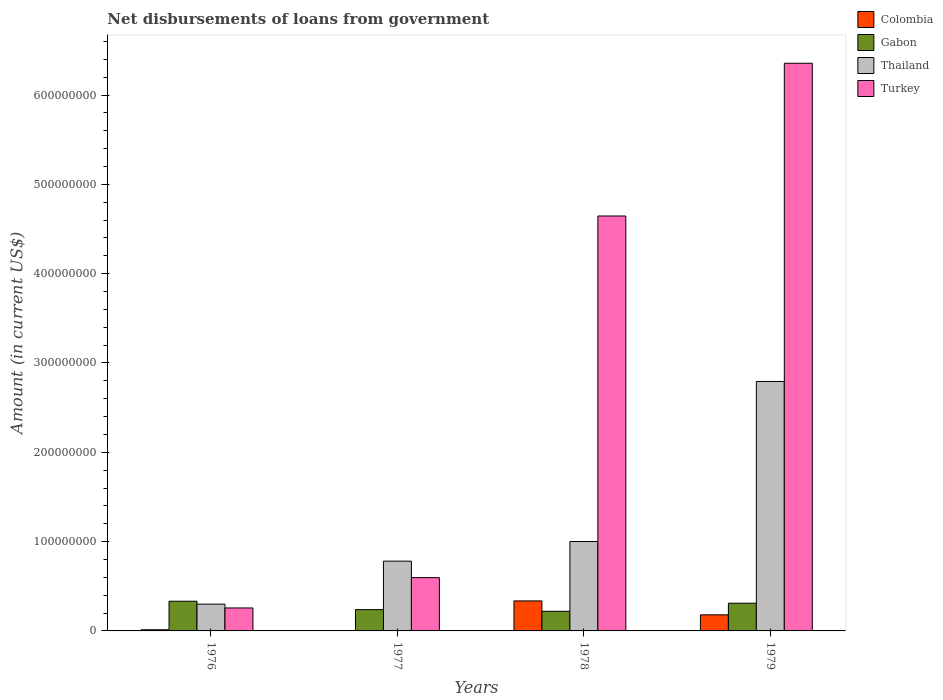How many different coloured bars are there?
Ensure brevity in your answer.  4. Are the number of bars on each tick of the X-axis equal?
Ensure brevity in your answer.  No. How many bars are there on the 2nd tick from the left?
Offer a very short reply. 3. What is the label of the 3rd group of bars from the left?
Your answer should be very brief. 1978. In how many cases, is the number of bars for a given year not equal to the number of legend labels?
Your answer should be very brief. 1. What is the amount of loan disbursed from government in Gabon in 1976?
Offer a terse response. 3.32e+07. Across all years, what is the maximum amount of loan disbursed from government in Thailand?
Offer a very short reply. 2.79e+08. Across all years, what is the minimum amount of loan disbursed from government in Gabon?
Your answer should be very brief. 2.20e+07. In which year was the amount of loan disbursed from government in Turkey maximum?
Your answer should be compact. 1979. What is the total amount of loan disbursed from government in Thailand in the graph?
Your answer should be very brief. 4.88e+08. What is the difference between the amount of loan disbursed from government in Thailand in 1976 and that in 1978?
Keep it short and to the point. -7.01e+07. What is the difference between the amount of loan disbursed from government in Gabon in 1978 and the amount of loan disbursed from government in Turkey in 1979?
Keep it short and to the point. -6.14e+08. What is the average amount of loan disbursed from government in Turkey per year?
Your answer should be compact. 2.96e+08. In the year 1976, what is the difference between the amount of loan disbursed from government in Thailand and amount of loan disbursed from government in Colombia?
Offer a terse response. 2.87e+07. What is the ratio of the amount of loan disbursed from government in Turkey in 1978 to that in 1979?
Your answer should be compact. 0.73. Is the amount of loan disbursed from government in Gabon in 1976 less than that in 1977?
Provide a succinct answer. No. What is the difference between the highest and the second highest amount of loan disbursed from government in Gabon?
Offer a very short reply. 2.24e+06. What is the difference between the highest and the lowest amount of loan disbursed from government in Colombia?
Provide a succinct answer. 3.36e+07. In how many years, is the amount of loan disbursed from government in Gabon greater than the average amount of loan disbursed from government in Gabon taken over all years?
Offer a very short reply. 2. Are the values on the major ticks of Y-axis written in scientific E-notation?
Keep it short and to the point. No. Does the graph contain any zero values?
Make the answer very short. Yes. Does the graph contain grids?
Your answer should be compact. No. How many legend labels are there?
Offer a very short reply. 4. How are the legend labels stacked?
Provide a short and direct response. Vertical. What is the title of the graph?
Provide a short and direct response. Net disbursements of loans from government. What is the Amount (in current US$) in Colombia in 1976?
Ensure brevity in your answer.  1.31e+06. What is the Amount (in current US$) of Gabon in 1976?
Give a very brief answer. 3.32e+07. What is the Amount (in current US$) in Thailand in 1976?
Keep it short and to the point. 3.00e+07. What is the Amount (in current US$) in Turkey in 1976?
Offer a terse response. 2.57e+07. What is the Amount (in current US$) of Colombia in 1977?
Keep it short and to the point. 0. What is the Amount (in current US$) in Gabon in 1977?
Keep it short and to the point. 2.38e+07. What is the Amount (in current US$) of Thailand in 1977?
Offer a terse response. 7.81e+07. What is the Amount (in current US$) in Turkey in 1977?
Provide a succinct answer. 5.97e+07. What is the Amount (in current US$) of Colombia in 1978?
Your response must be concise. 3.36e+07. What is the Amount (in current US$) in Gabon in 1978?
Offer a very short reply. 2.20e+07. What is the Amount (in current US$) of Thailand in 1978?
Your answer should be compact. 1.00e+08. What is the Amount (in current US$) in Turkey in 1978?
Make the answer very short. 4.65e+08. What is the Amount (in current US$) in Colombia in 1979?
Offer a very short reply. 1.80e+07. What is the Amount (in current US$) in Gabon in 1979?
Keep it short and to the point. 3.10e+07. What is the Amount (in current US$) of Thailand in 1979?
Provide a succinct answer. 2.79e+08. What is the Amount (in current US$) in Turkey in 1979?
Ensure brevity in your answer.  6.36e+08. Across all years, what is the maximum Amount (in current US$) of Colombia?
Keep it short and to the point. 3.36e+07. Across all years, what is the maximum Amount (in current US$) of Gabon?
Your response must be concise. 3.32e+07. Across all years, what is the maximum Amount (in current US$) of Thailand?
Your answer should be very brief. 2.79e+08. Across all years, what is the maximum Amount (in current US$) in Turkey?
Your answer should be compact. 6.36e+08. Across all years, what is the minimum Amount (in current US$) in Colombia?
Provide a succinct answer. 0. Across all years, what is the minimum Amount (in current US$) of Gabon?
Offer a very short reply. 2.20e+07. Across all years, what is the minimum Amount (in current US$) in Thailand?
Offer a terse response. 3.00e+07. Across all years, what is the minimum Amount (in current US$) of Turkey?
Your response must be concise. 2.57e+07. What is the total Amount (in current US$) of Colombia in the graph?
Offer a terse response. 5.29e+07. What is the total Amount (in current US$) of Gabon in the graph?
Your answer should be very brief. 1.10e+08. What is the total Amount (in current US$) of Thailand in the graph?
Provide a succinct answer. 4.88e+08. What is the total Amount (in current US$) in Turkey in the graph?
Offer a terse response. 1.19e+09. What is the difference between the Amount (in current US$) in Gabon in 1976 and that in 1977?
Make the answer very short. 9.41e+06. What is the difference between the Amount (in current US$) in Thailand in 1976 and that in 1977?
Make the answer very short. -4.81e+07. What is the difference between the Amount (in current US$) of Turkey in 1976 and that in 1977?
Offer a very short reply. -3.40e+07. What is the difference between the Amount (in current US$) in Colombia in 1976 and that in 1978?
Offer a terse response. -3.23e+07. What is the difference between the Amount (in current US$) of Gabon in 1976 and that in 1978?
Offer a terse response. 1.13e+07. What is the difference between the Amount (in current US$) in Thailand in 1976 and that in 1978?
Keep it short and to the point. -7.01e+07. What is the difference between the Amount (in current US$) of Turkey in 1976 and that in 1978?
Make the answer very short. -4.39e+08. What is the difference between the Amount (in current US$) in Colombia in 1976 and that in 1979?
Provide a short and direct response. -1.67e+07. What is the difference between the Amount (in current US$) of Gabon in 1976 and that in 1979?
Make the answer very short. 2.24e+06. What is the difference between the Amount (in current US$) of Thailand in 1976 and that in 1979?
Your response must be concise. -2.49e+08. What is the difference between the Amount (in current US$) in Turkey in 1976 and that in 1979?
Give a very brief answer. -6.10e+08. What is the difference between the Amount (in current US$) of Gabon in 1977 and that in 1978?
Provide a succinct answer. 1.84e+06. What is the difference between the Amount (in current US$) of Thailand in 1977 and that in 1978?
Your answer should be compact. -2.20e+07. What is the difference between the Amount (in current US$) of Turkey in 1977 and that in 1978?
Ensure brevity in your answer.  -4.05e+08. What is the difference between the Amount (in current US$) of Gabon in 1977 and that in 1979?
Provide a succinct answer. -7.17e+06. What is the difference between the Amount (in current US$) of Thailand in 1977 and that in 1979?
Keep it short and to the point. -2.01e+08. What is the difference between the Amount (in current US$) in Turkey in 1977 and that in 1979?
Offer a very short reply. -5.76e+08. What is the difference between the Amount (in current US$) in Colombia in 1978 and that in 1979?
Offer a very short reply. 1.56e+07. What is the difference between the Amount (in current US$) of Gabon in 1978 and that in 1979?
Ensure brevity in your answer.  -9.01e+06. What is the difference between the Amount (in current US$) of Thailand in 1978 and that in 1979?
Give a very brief answer. -1.79e+08. What is the difference between the Amount (in current US$) in Turkey in 1978 and that in 1979?
Provide a short and direct response. -1.71e+08. What is the difference between the Amount (in current US$) of Colombia in 1976 and the Amount (in current US$) of Gabon in 1977?
Ensure brevity in your answer.  -2.25e+07. What is the difference between the Amount (in current US$) in Colombia in 1976 and the Amount (in current US$) in Thailand in 1977?
Provide a succinct answer. -7.68e+07. What is the difference between the Amount (in current US$) in Colombia in 1976 and the Amount (in current US$) in Turkey in 1977?
Your response must be concise. -5.84e+07. What is the difference between the Amount (in current US$) in Gabon in 1976 and the Amount (in current US$) in Thailand in 1977?
Provide a short and direct response. -4.49e+07. What is the difference between the Amount (in current US$) in Gabon in 1976 and the Amount (in current US$) in Turkey in 1977?
Offer a very short reply. -2.64e+07. What is the difference between the Amount (in current US$) in Thailand in 1976 and the Amount (in current US$) in Turkey in 1977?
Offer a very short reply. -2.97e+07. What is the difference between the Amount (in current US$) in Colombia in 1976 and the Amount (in current US$) in Gabon in 1978?
Keep it short and to the point. -2.07e+07. What is the difference between the Amount (in current US$) of Colombia in 1976 and the Amount (in current US$) of Thailand in 1978?
Give a very brief answer. -9.88e+07. What is the difference between the Amount (in current US$) in Colombia in 1976 and the Amount (in current US$) in Turkey in 1978?
Your response must be concise. -4.63e+08. What is the difference between the Amount (in current US$) of Gabon in 1976 and the Amount (in current US$) of Thailand in 1978?
Provide a succinct answer. -6.69e+07. What is the difference between the Amount (in current US$) in Gabon in 1976 and the Amount (in current US$) in Turkey in 1978?
Offer a terse response. -4.31e+08. What is the difference between the Amount (in current US$) in Thailand in 1976 and the Amount (in current US$) in Turkey in 1978?
Offer a terse response. -4.35e+08. What is the difference between the Amount (in current US$) of Colombia in 1976 and the Amount (in current US$) of Gabon in 1979?
Give a very brief answer. -2.97e+07. What is the difference between the Amount (in current US$) of Colombia in 1976 and the Amount (in current US$) of Thailand in 1979?
Provide a short and direct response. -2.78e+08. What is the difference between the Amount (in current US$) in Colombia in 1976 and the Amount (in current US$) in Turkey in 1979?
Give a very brief answer. -6.34e+08. What is the difference between the Amount (in current US$) in Gabon in 1976 and the Amount (in current US$) in Thailand in 1979?
Make the answer very short. -2.46e+08. What is the difference between the Amount (in current US$) in Gabon in 1976 and the Amount (in current US$) in Turkey in 1979?
Provide a succinct answer. -6.02e+08. What is the difference between the Amount (in current US$) of Thailand in 1976 and the Amount (in current US$) of Turkey in 1979?
Offer a terse response. -6.06e+08. What is the difference between the Amount (in current US$) in Gabon in 1977 and the Amount (in current US$) in Thailand in 1978?
Your answer should be compact. -7.63e+07. What is the difference between the Amount (in current US$) of Gabon in 1977 and the Amount (in current US$) of Turkey in 1978?
Give a very brief answer. -4.41e+08. What is the difference between the Amount (in current US$) of Thailand in 1977 and the Amount (in current US$) of Turkey in 1978?
Offer a very short reply. -3.86e+08. What is the difference between the Amount (in current US$) of Gabon in 1977 and the Amount (in current US$) of Thailand in 1979?
Provide a succinct answer. -2.55e+08. What is the difference between the Amount (in current US$) of Gabon in 1977 and the Amount (in current US$) of Turkey in 1979?
Provide a short and direct response. -6.12e+08. What is the difference between the Amount (in current US$) of Thailand in 1977 and the Amount (in current US$) of Turkey in 1979?
Give a very brief answer. -5.57e+08. What is the difference between the Amount (in current US$) in Colombia in 1978 and the Amount (in current US$) in Gabon in 1979?
Your response must be concise. 2.59e+06. What is the difference between the Amount (in current US$) in Colombia in 1978 and the Amount (in current US$) in Thailand in 1979?
Offer a very short reply. -2.46e+08. What is the difference between the Amount (in current US$) in Colombia in 1978 and the Amount (in current US$) in Turkey in 1979?
Your answer should be very brief. -6.02e+08. What is the difference between the Amount (in current US$) of Gabon in 1978 and the Amount (in current US$) of Thailand in 1979?
Provide a succinct answer. -2.57e+08. What is the difference between the Amount (in current US$) in Gabon in 1978 and the Amount (in current US$) in Turkey in 1979?
Keep it short and to the point. -6.14e+08. What is the difference between the Amount (in current US$) in Thailand in 1978 and the Amount (in current US$) in Turkey in 1979?
Your answer should be very brief. -5.36e+08. What is the average Amount (in current US$) of Colombia per year?
Provide a succinct answer. 1.32e+07. What is the average Amount (in current US$) in Gabon per year?
Your answer should be very brief. 2.75e+07. What is the average Amount (in current US$) in Thailand per year?
Offer a very short reply. 1.22e+08. What is the average Amount (in current US$) in Turkey per year?
Offer a very short reply. 2.96e+08. In the year 1976, what is the difference between the Amount (in current US$) in Colombia and Amount (in current US$) in Gabon?
Give a very brief answer. -3.19e+07. In the year 1976, what is the difference between the Amount (in current US$) in Colombia and Amount (in current US$) in Thailand?
Ensure brevity in your answer.  -2.87e+07. In the year 1976, what is the difference between the Amount (in current US$) in Colombia and Amount (in current US$) in Turkey?
Your answer should be very brief. -2.44e+07. In the year 1976, what is the difference between the Amount (in current US$) of Gabon and Amount (in current US$) of Thailand?
Ensure brevity in your answer.  3.23e+06. In the year 1976, what is the difference between the Amount (in current US$) of Gabon and Amount (in current US$) of Turkey?
Ensure brevity in your answer.  7.54e+06. In the year 1976, what is the difference between the Amount (in current US$) of Thailand and Amount (in current US$) of Turkey?
Ensure brevity in your answer.  4.31e+06. In the year 1977, what is the difference between the Amount (in current US$) in Gabon and Amount (in current US$) in Thailand?
Give a very brief answer. -5.43e+07. In the year 1977, what is the difference between the Amount (in current US$) of Gabon and Amount (in current US$) of Turkey?
Keep it short and to the point. -3.58e+07. In the year 1977, what is the difference between the Amount (in current US$) in Thailand and Amount (in current US$) in Turkey?
Offer a very short reply. 1.84e+07. In the year 1978, what is the difference between the Amount (in current US$) of Colombia and Amount (in current US$) of Gabon?
Your response must be concise. 1.16e+07. In the year 1978, what is the difference between the Amount (in current US$) of Colombia and Amount (in current US$) of Thailand?
Your answer should be very brief. -6.65e+07. In the year 1978, what is the difference between the Amount (in current US$) in Colombia and Amount (in current US$) in Turkey?
Offer a terse response. -4.31e+08. In the year 1978, what is the difference between the Amount (in current US$) in Gabon and Amount (in current US$) in Thailand?
Give a very brief answer. -7.81e+07. In the year 1978, what is the difference between the Amount (in current US$) in Gabon and Amount (in current US$) in Turkey?
Offer a very short reply. -4.43e+08. In the year 1978, what is the difference between the Amount (in current US$) of Thailand and Amount (in current US$) of Turkey?
Provide a short and direct response. -3.65e+08. In the year 1979, what is the difference between the Amount (in current US$) in Colombia and Amount (in current US$) in Gabon?
Your answer should be compact. -1.30e+07. In the year 1979, what is the difference between the Amount (in current US$) of Colombia and Amount (in current US$) of Thailand?
Keep it short and to the point. -2.61e+08. In the year 1979, what is the difference between the Amount (in current US$) in Colombia and Amount (in current US$) in Turkey?
Provide a succinct answer. -6.18e+08. In the year 1979, what is the difference between the Amount (in current US$) of Gabon and Amount (in current US$) of Thailand?
Your answer should be very brief. -2.48e+08. In the year 1979, what is the difference between the Amount (in current US$) in Gabon and Amount (in current US$) in Turkey?
Your answer should be very brief. -6.05e+08. In the year 1979, what is the difference between the Amount (in current US$) in Thailand and Amount (in current US$) in Turkey?
Your answer should be very brief. -3.56e+08. What is the ratio of the Amount (in current US$) in Gabon in 1976 to that in 1977?
Provide a short and direct response. 1.39. What is the ratio of the Amount (in current US$) in Thailand in 1976 to that in 1977?
Your answer should be very brief. 0.38. What is the ratio of the Amount (in current US$) in Turkey in 1976 to that in 1977?
Your answer should be compact. 0.43. What is the ratio of the Amount (in current US$) of Colombia in 1976 to that in 1978?
Provide a short and direct response. 0.04. What is the ratio of the Amount (in current US$) of Gabon in 1976 to that in 1978?
Provide a succinct answer. 1.51. What is the ratio of the Amount (in current US$) in Thailand in 1976 to that in 1978?
Provide a succinct answer. 0.3. What is the ratio of the Amount (in current US$) in Turkey in 1976 to that in 1978?
Keep it short and to the point. 0.06. What is the ratio of the Amount (in current US$) of Colombia in 1976 to that in 1979?
Your answer should be very brief. 0.07. What is the ratio of the Amount (in current US$) of Gabon in 1976 to that in 1979?
Your response must be concise. 1.07. What is the ratio of the Amount (in current US$) in Thailand in 1976 to that in 1979?
Offer a very short reply. 0.11. What is the ratio of the Amount (in current US$) in Turkey in 1976 to that in 1979?
Ensure brevity in your answer.  0.04. What is the ratio of the Amount (in current US$) in Gabon in 1977 to that in 1978?
Provide a succinct answer. 1.08. What is the ratio of the Amount (in current US$) in Thailand in 1977 to that in 1978?
Your answer should be compact. 0.78. What is the ratio of the Amount (in current US$) of Turkey in 1977 to that in 1978?
Your answer should be compact. 0.13. What is the ratio of the Amount (in current US$) in Gabon in 1977 to that in 1979?
Offer a terse response. 0.77. What is the ratio of the Amount (in current US$) of Thailand in 1977 to that in 1979?
Make the answer very short. 0.28. What is the ratio of the Amount (in current US$) in Turkey in 1977 to that in 1979?
Provide a succinct answer. 0.09. What is the ratio of the Amount (in current US$) of Colombia in 1978 to that in 1979?
Your answer should be compact. 1.86. What is the ratio of the Amount (in current US$) in Gabon in 1978 to that in 1979?
Ensure brevity in your answer.  0.71. What is the ratio of the Amount (in current US$) of Thailand in 1978 to that in 1979?
Provide a succinct answer. 0.36. What is the ratio of the Amount (in current US$) in Turkey in 1978 to that in 1979?
Your answer should be compact. 0.73. What is the difference between the highest and the second highest Amount (in current US$) in Colombia?
Provide a succinct answer. 1.56e+07. What is the difference between the highest and the second highest Amount (in current US$) in Gabon?
Provide a short and direct response. 2.24e+06. What is the difference between the highest and the second highest Amount (in current US$) in Thailand?
Ensure brevity in your answer.  1.79e+08. What is the difference between the highest and the second highest Amount (in current US$) of Turkey?
Ensure brevity in your answer.  1.71e+08. What is the difference between the highest and the lowest Amount (in current US$) in Colombia?
Provide a short and direct response. 3.36e+07. What is the difference between the highest and the lowest Amount (in current US$) of Gabon?
Your answer should be compact. 1.13e+07. What is the difference between the highest and the lowest Amount (in current US$) of Thailand?
Make the answer very short. 2.49e+08. What is the difference between the highest and the lowest Amount (in current US$) of Turkey?
Give a very brief answer. 6.10e+08. 